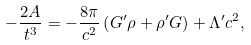Convert formula to latex. <formula><loc_0><loc_0><loc_500><loc_500>- \frac { 2 A } { t ^ { 3 } } = - \frac { 8 \pi } { c ^ { 2 } } \left ( G ^ { \prime } \rho + \rho ^ { \prime } G \right ) + \Lambda ^ { \prime } c ^ { 2 } ,</formula> 